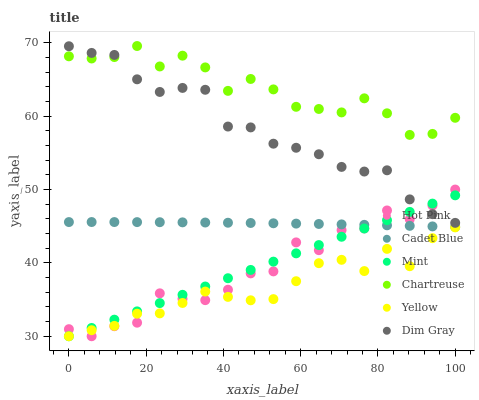Does Yellow have the minimum area under the curve?
Answer yes or no. Yes. Does Chartreuse have the maximum area under the curve?
Answer yes or no. Yes. Does Hot Pink have the minimum area under the curve?
Answer yes or no. No. Does Hot Pink have the maximum area under the curve?
Answer yes or no. No. Is Mint the smoothest?
Answer yes or no. Yes. Is Hot Pink the roughest?
Answer yes or no. Yes. Is Yellow the smoothest?
Answer yes or no. No. Is Yellow the roughest?
Answer yes or no. No. Does Hot Pink have the lowest value?
Answer yes or no. Yes. Does Chartreuse have the lowest value?
Answer yes or no. No. Does Chartreuse have the highest value?
Answer yes or no. Yes. Does Hot Pink have the highest value?
Answer yes or no. No. Is Cadet Blue less than Dim Gray?
Answer yes or no. Yes. Is Chartreuse greater than Yellow?
Answer yes or no. Yes. Does Dim Gray intersect Mint?
Answer yes or no. Yes. Is Dim Gray less than Mint?
Answer yes or no. No. Is Dim Gray greater than Mint?
Answer yes or no. No. Does Cadet Blue intersect Dim Gray?
Answer yes or no. No. 